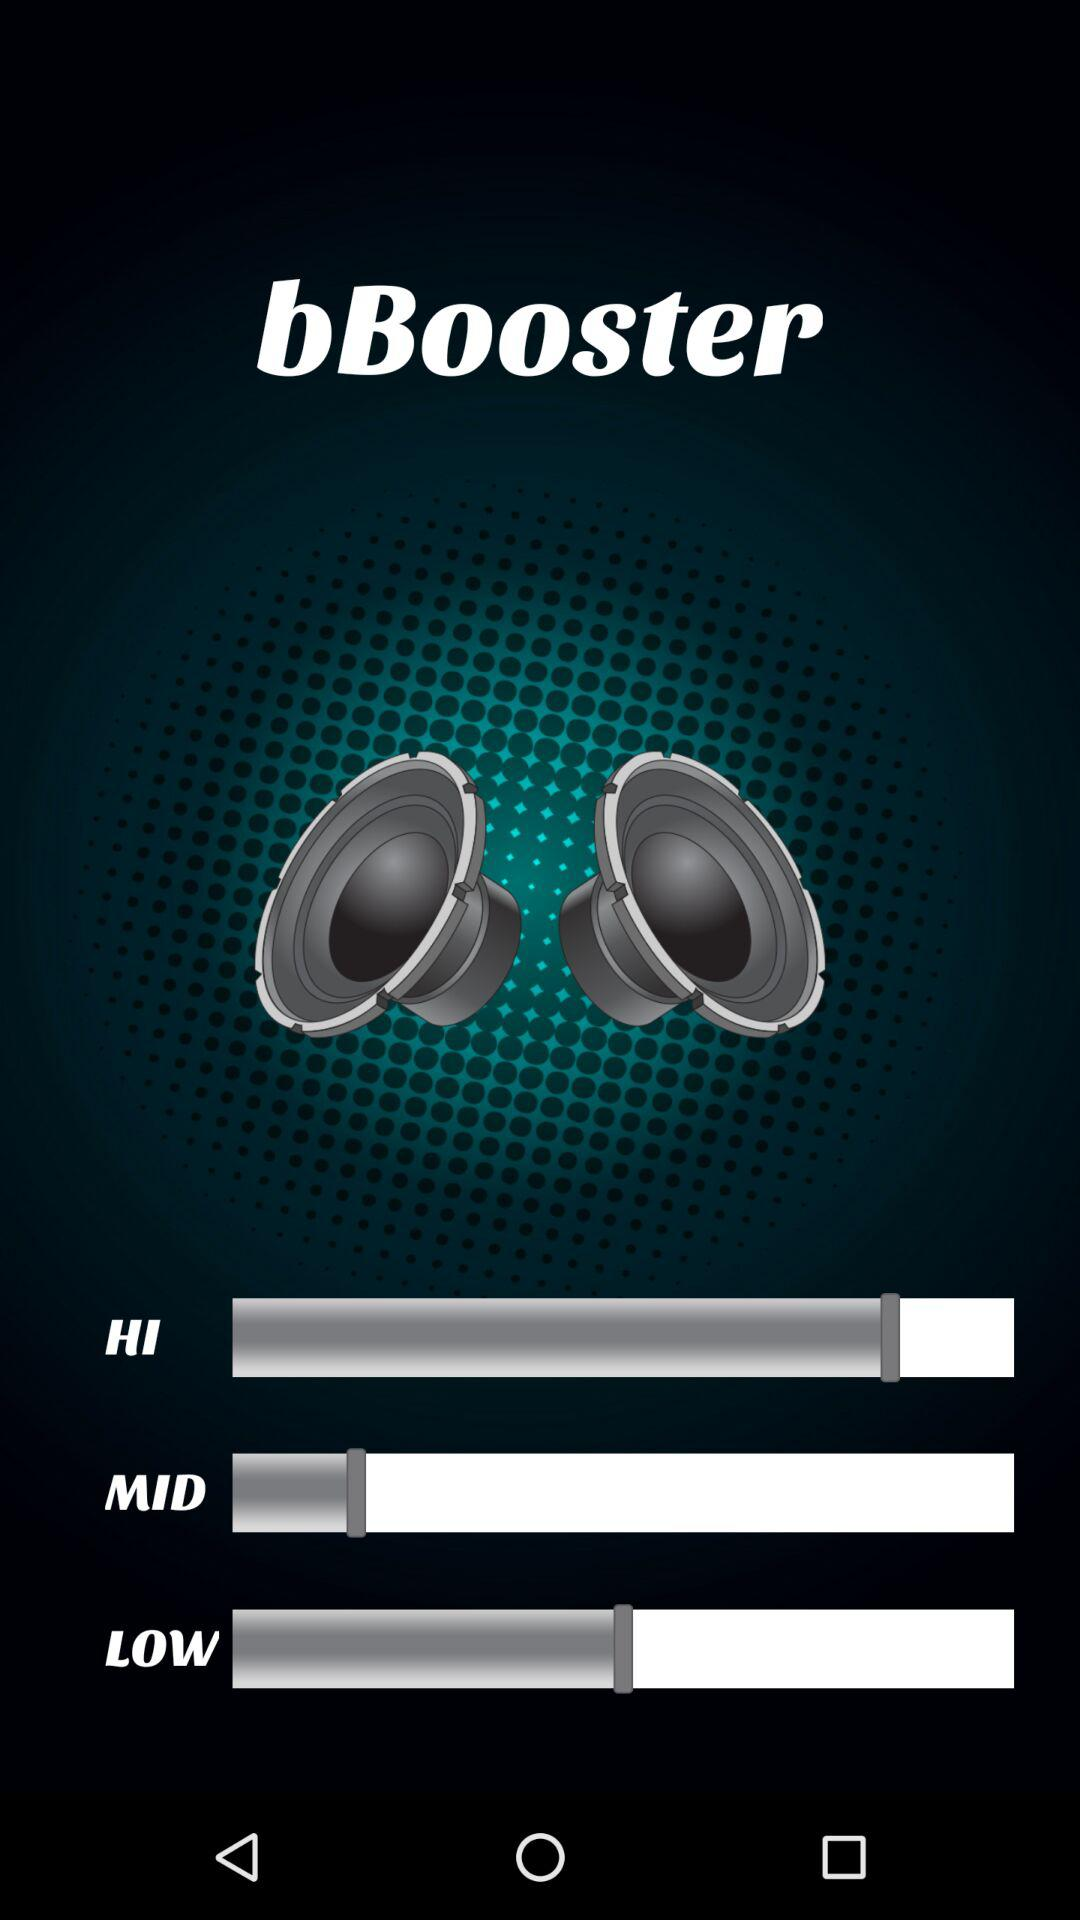What is the name of the application? The name of the application is "bBooster". 